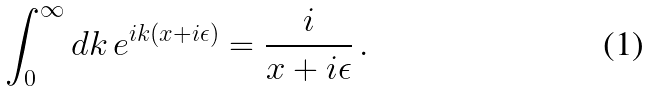Convert formula to latex. <formula><loc_0><loc_0><loc_500><loc_500>\int _ { 0 } ^ { \infty } d k \, e ^ { i k ( x + i \epsilon ) } = \frac { i } { x + i \epsilon } \, .</formula> 